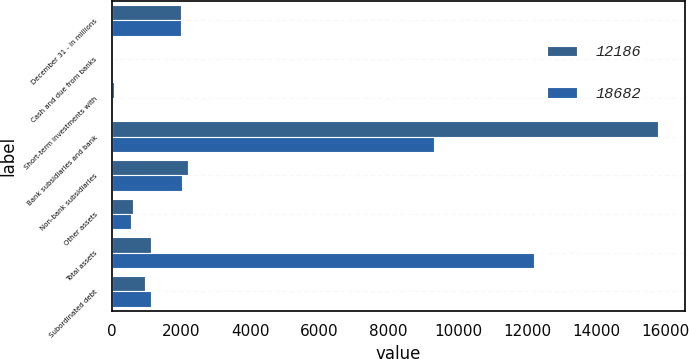<chart> <loc_0><loc_0><loc_500><loc_500><stacked_bar_chart><ecel><fcel>December 31 - in millions<fcel>Cash and due from banks<fcel>Short-term investments with<fcel>Bank subsidiaries and bank<fcel>Non-bank subsidiaries<fcel>Other assets<fcel>Total assets<fcel>Subordinated debt<nl><fcel>12186<fcel>2007<fcel>20<fcel>58<fcel>15776<fcel>2214<fcel>614<fcel>1147<fcel>968<nl><fcel>18682<fcel>2006<fcel>2<fcel>3<fcel>9294<fcel>2038<fcel>559<fcel>12186<fcel>1147<nl></chart> 